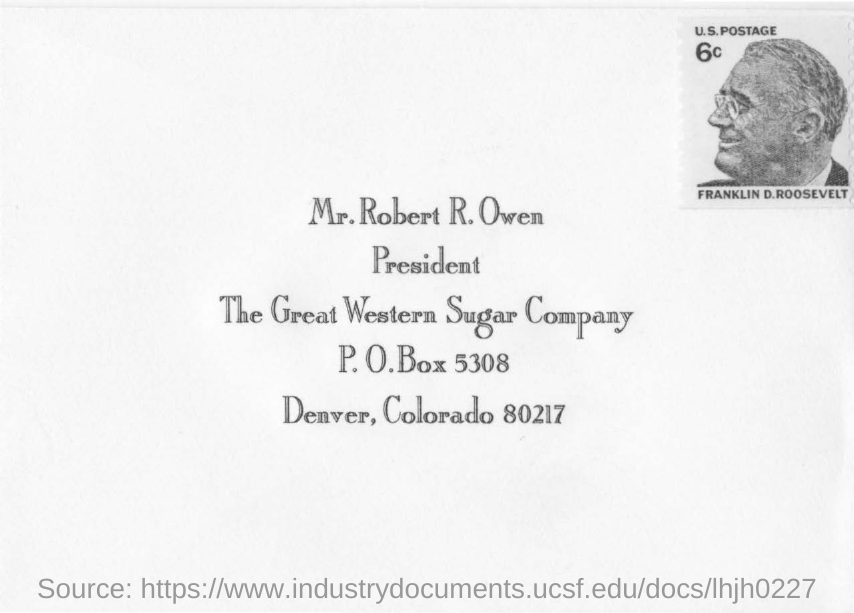Who's postage at the top leftside of the envelope?
Offer a terse response. Franklin D.Roosevelt. Whose name is mentioned in the postal address?
Ensure brevity in your answer.  Mr. Robert R. Owen. What is the post office box number?
Provide a short and direct response. 5308. Which company is mentioned on the envelope ?
Make the answer very short. The Great Western Sugar Company. 